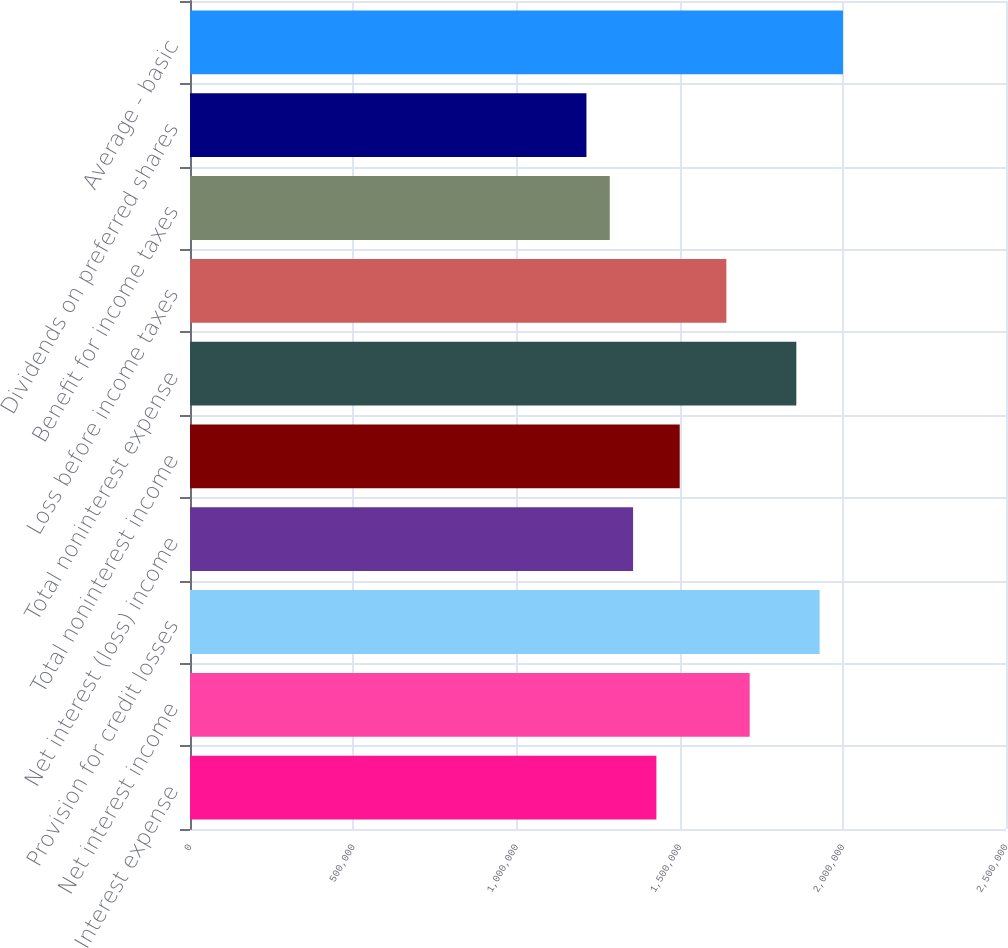<chart> <loc_0><loc_0><loc_500><loc_500><bar_chart><fcel>Interest expense<fcel>Net interest income<fcel>Provision for credit losses<fcel>Net interest (loss) income<fcel>Total noninterest income<fcel>Total noninterest expense<fcel>Loss before income taxes<fcel>Benefit for income taxes<fcel>Dividends on preferred shares<fcel>Average - basic<nl><fcel>1.42894e+06<fcel>1.71473e+06<fcel>1.92907e+06<fcel>1.35749e+06<fcel>1.50038e+06<fcel>1.85762e+06<fcel>1.64328e+06<fcel>1.28604e+06<fcel>1.2146e+06<fcel>2.00051e+06<nl></chart> 